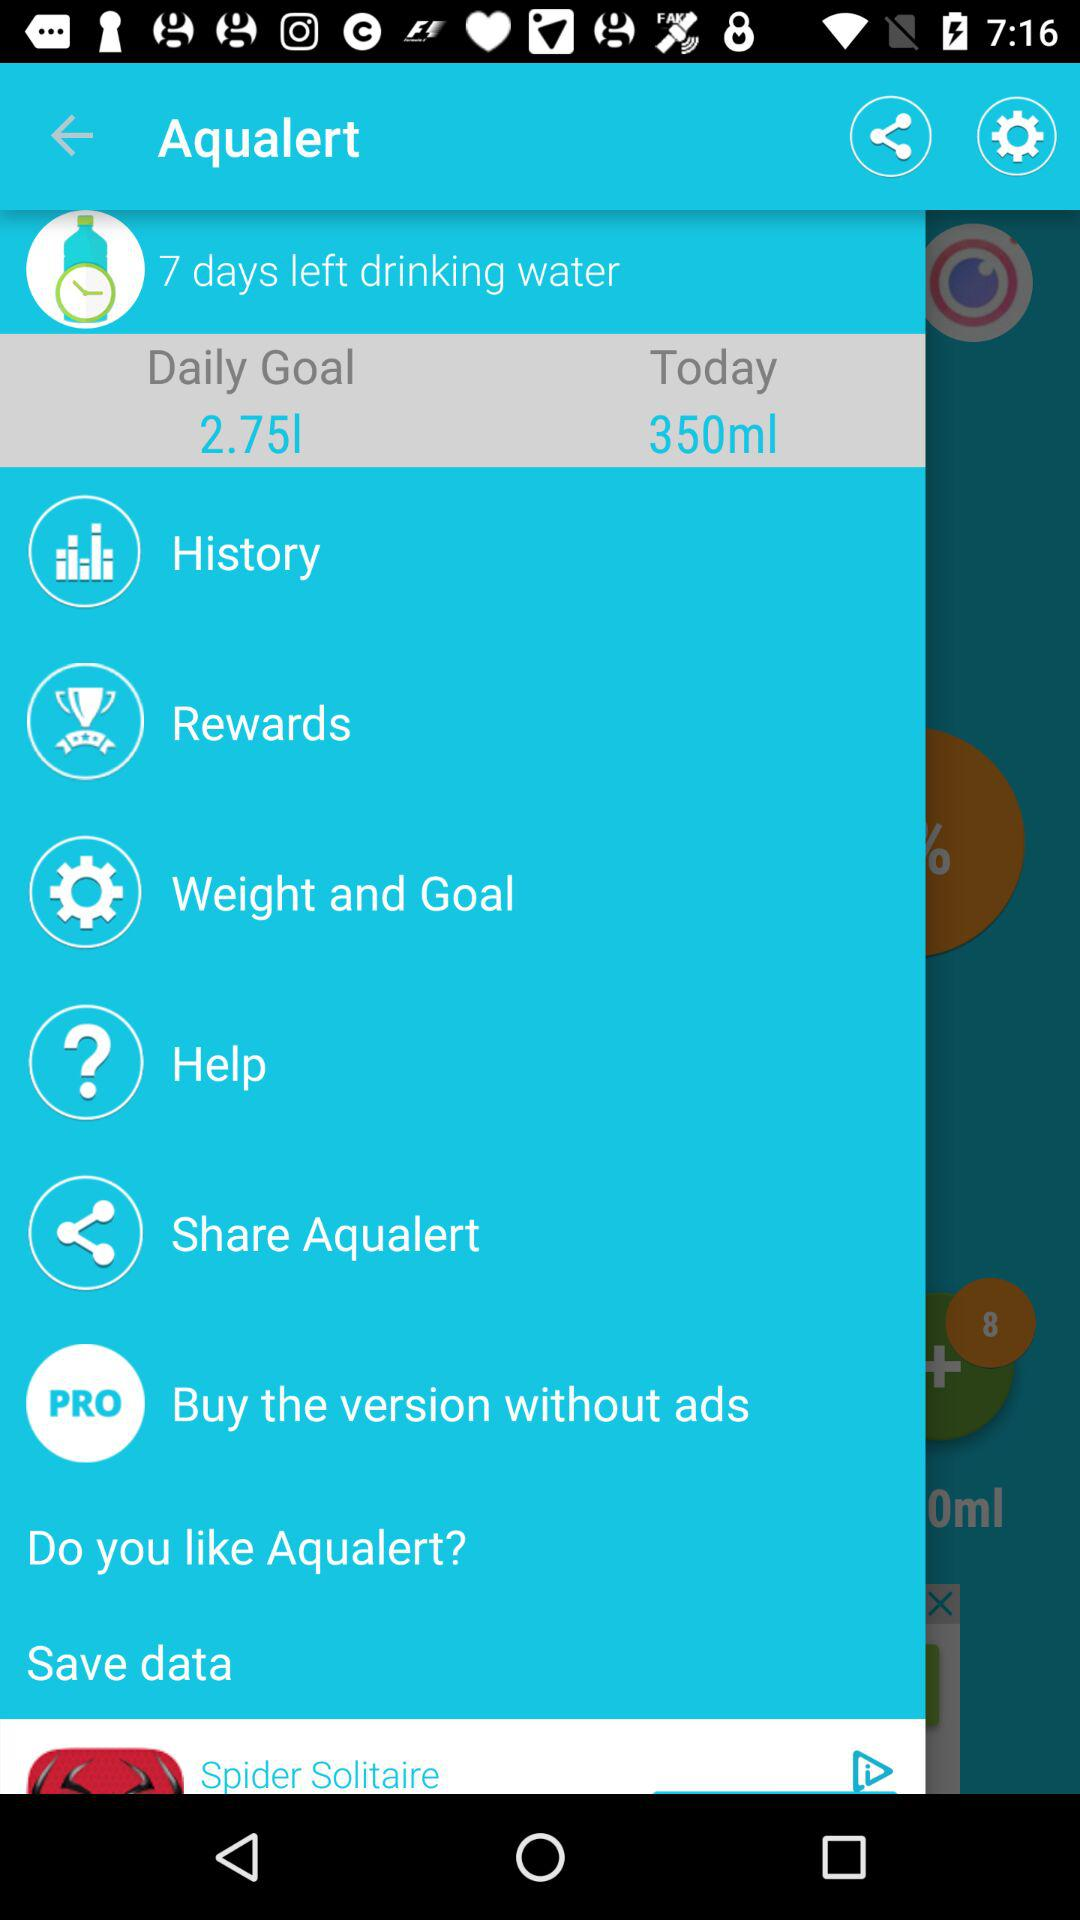How many milliliters of water do I have to drink today?
Answer the question using a single word or phrase. 350ml 